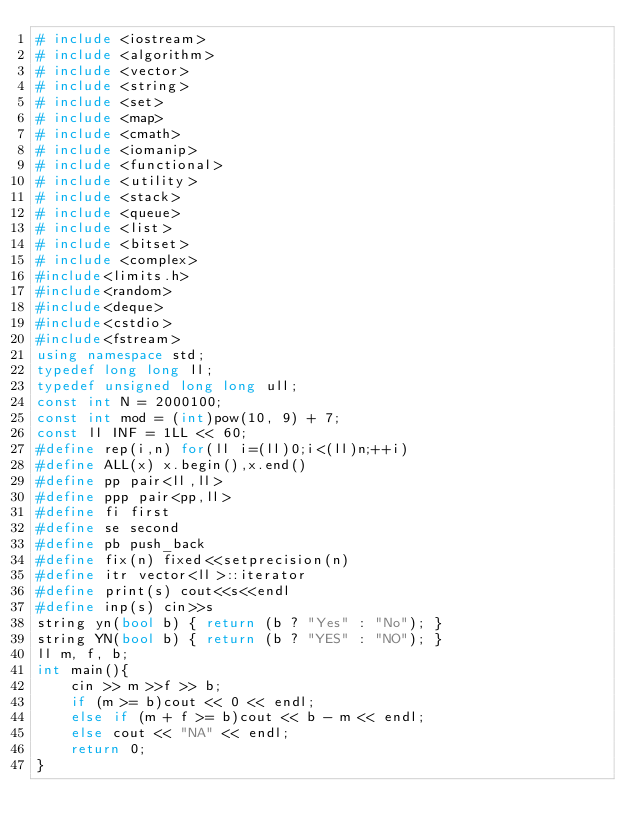Convert code to text. <code><loc_0><loc_0><loc_500><loc_500><_C++_># include <iostream>
# include <algorithm>
# include <vector>
# include <string>
# include <set>
# include <map>
# include <cmath>
# include <iomanip>
# include <functional>
# include <utility>
# include <stack>
# include <queue>
# include <list>
# include <bitset>
# include <complex>
#include<limits.h>
#include<random>
#include<deque>
#include<cstdio>
#include<fstream>
using namespace std;
typedef long long ll;
typedef unsigned long long ull;
const int N = 2000100;
const int mod = (int)pow(10, 9) + 7;
const ll INF = 1LL << 60;
#define rep(i,n) for(ll i=(ll)0;i<(ll)n;++i)
#define ALL(x) x.begin(),x.end()
#define pp pair<ll,ll>
#define ppp pair<pp,ll>
#define fi first
#define se second
#define pb push_back
#define fix(n) fixed<<setprecision(n)
#define itr vector<ll>::iterator
#define print(s) cout<<s<<endl
#define inp(s) cin>>s
string yn(bool b) { return (b ? "Yes" : "No"); }
string YN(bool b) { return (b ? "YES" : "NO"); }
ll m, f, b;
int main(){
	cin >> m >>f >> b;
	if (m >= b)cout << 0 << endl;
	else if (m + f >= b)cout << b - m << endl;
	else cout << "NA" << endl;
	return 0;
}
</code> 